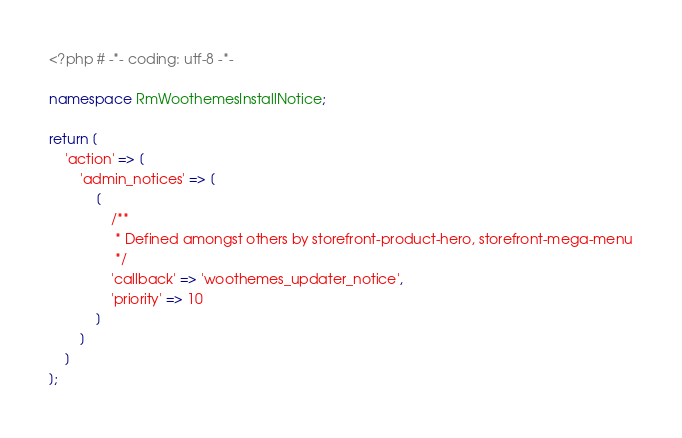<code> <loc_0><loc_0><loc_500><loc_500><_PHP_><?php # -*- coding: utf-8 -*-

namespace RmWoothemesInstallNotice;

return [
	'action' => [
		'admin_notices' => [
			[
				/**
				 * Defined amongst others by storefront-product-hero, storefront-mega-menu
				 */
				'callback' => 'woothemes_updater_notice',
				'priority' => 10
			]
		]
	]
];</code> 